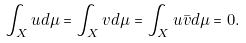<formula> <loc_0><loc_0><loc_500><loc_500>\int _ { X } u d \mu = \int _ { X } v d \mu = \int _ { X } u \bar { v } d \mu = 0 .</formula> 